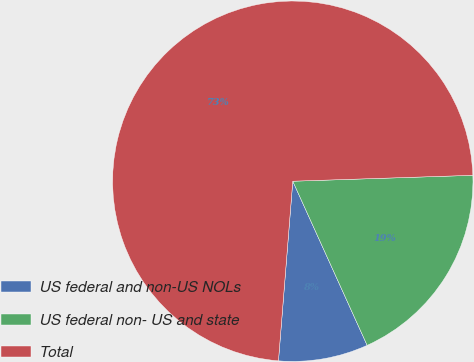Convert chart. <chart><loc_0><loc_0><loc_500><loc_500><pie_chart><fcel>US federal and non-US NOLs<fcel>US federal non- US and state<fcel>Total<nl><fcel>8.04%<fcel>18.75%<fcel>73.21%<nl></chart> 